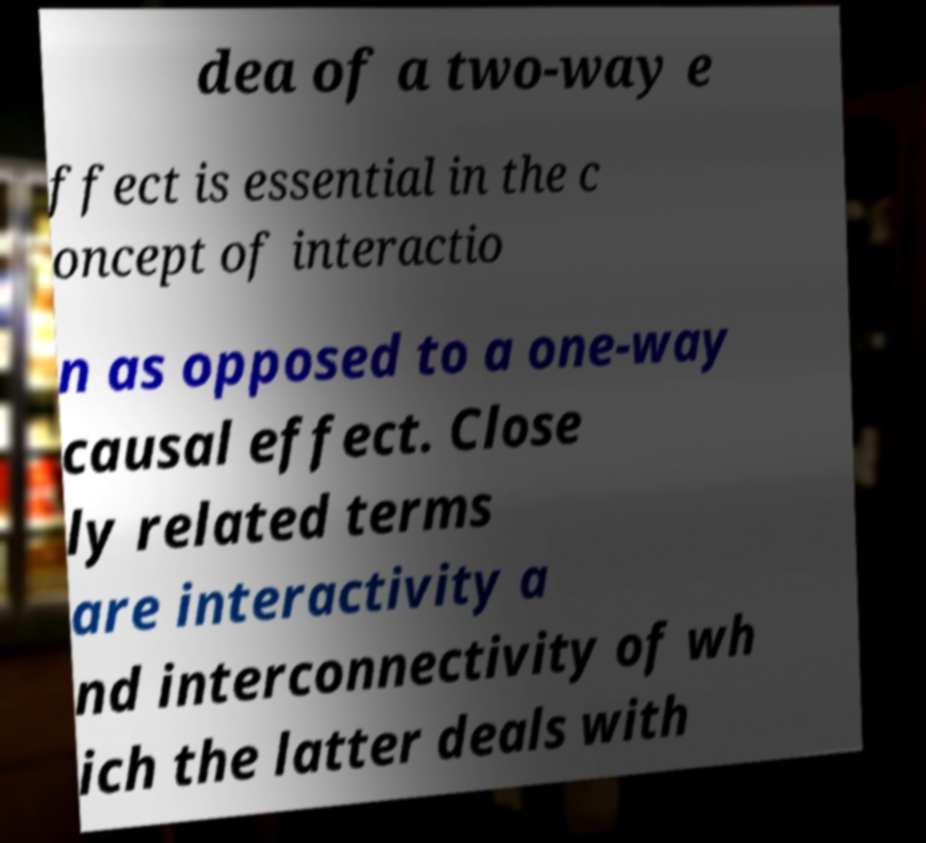Please read and relay the text visible in this image. What does it say? dea of a two-way e ffect is essential in the c oncept of interactio n as opposed to a one-way causal effect. Close ly related terms are interactivity a nd interconnectivity of wh ich the latter deals with 